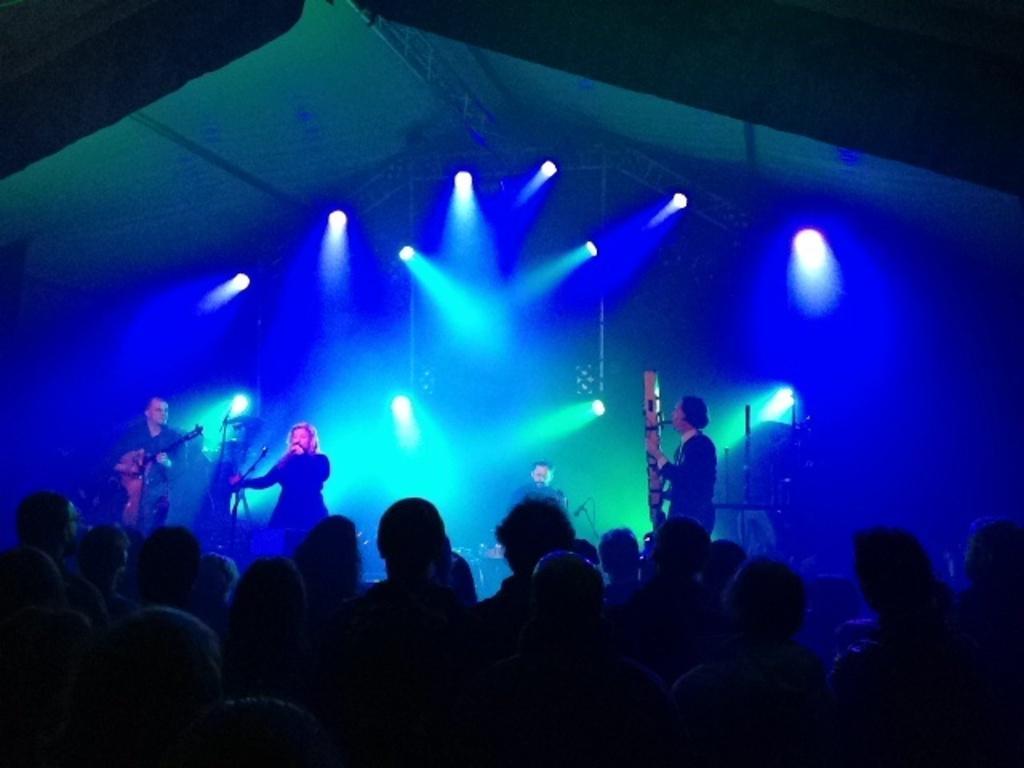Please provide a concise description of this image. In this image, we can see some people standing and there are some people standing on the stage and they are holding music instruments, we can see some lights. 